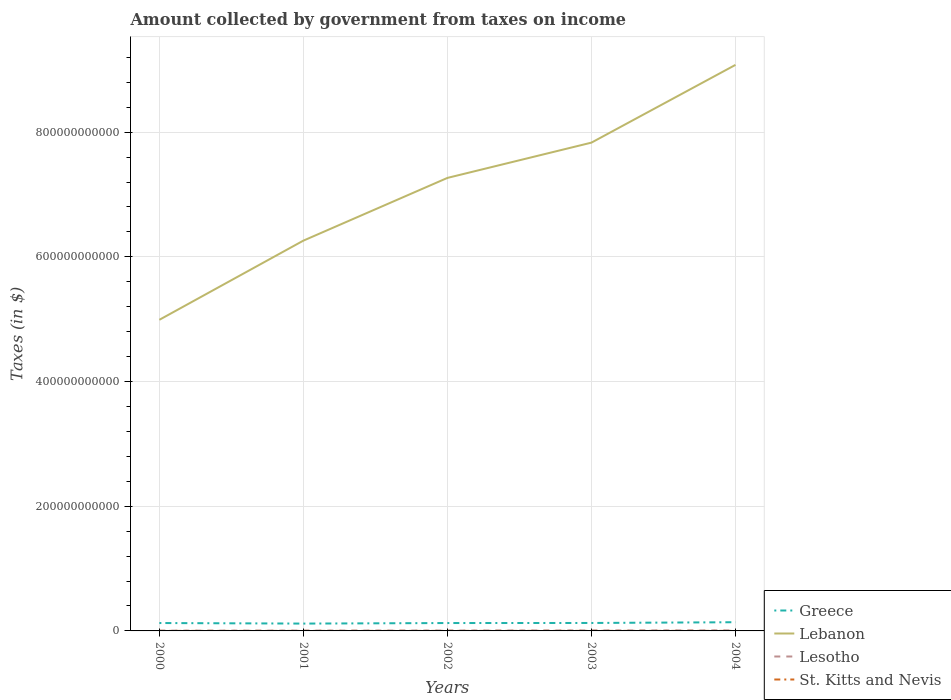How many different coloured lines are there?
Your response must be concise. 4. Across all years, what is the maximum amount collected by government from taxes on income in St. Kitts and Nevis?
Make the answer very short. 5.77e+07. In which year was the amount collected by government from taxes on income in St. Kitts and Nevis maximum?
Make the answer very short. 2001. What is the total amount collected by government from taxes on income in Lebanon in the graph?
Make the answer very short. -1.81e+11. What is the difference between the highest and the second highest amount collected by government from taxes on income in Greece?
Ensure brevity in your answer.  2.20e+09. How many lines are there?
Keep it short and to the point. 4. How many years are there in the graph?
Keep it short and to the point. 5. What is the difference between two consecutive major ticks on the Y-axis?
Offer a terse response. 2.00e+11. Are the values on the major ticks of Y-axis written in scientific E-notation?
Ensure brevity in your answer.  No. Does the graph contain any zero values?
Give a very brief answer. No. Does the graph contain grids?
Make the answer very short. Yes. Where does the legend appear in the graph?
Provide a succinct answer. Bottom right. How many legend labels are there?
Ensure brevity in your answer.  4. How are the legend labels stacked?
Provide a succinct answer. Vertical. What is the title of the graph?
Offer a very short reply. Amount collected by government from taxes on income. What is the label or title of the X-axis?
Your answer should be very brief. Years. What is the label or title of the Y-axis?
Ensure brevity in your answer.  Taxes (in $). What is the Taxes (in $) in Greece in 2000?
Your answer should be compact. 1.27e+1. What is the Taxes (in $) in Lebanon in 2000?
Your answer should be compact. 4.99e+11. What is the Taxes (in $) in Lesotho in 2000?
Your answer should be very brief. 4.68e+08. What is the Taxes (in $) in St. Kitts and Nevis in 2000?
Your response must be concise. 5.92e+07. What is the Taxes (in $) in Greece in 2001?
Offer a very short reply. 1.18e+1. What is the Taxes (in $) in Lebanon in 2001?
Your answer should be very brief. 6.26e+11. What is the Taxes (in $) of Lesotho in 2001?
Keep it short and to the point. 5.80e+08. What is the Taxes (in $) in St. Kitts and Nevis in 2001?
Your answer should be very brief. 5.77e+07. What is the Taxes (in $) of Greece in 2002?
Keep it short and to the point. 1.26e+1. What is the Taxes (in $) of Lebanon in 2002?
Provide a short and direct response. 7.27e+11. What is the Taxes (in $) of Lesotho in 2002?
Your answer should be very brief. 6.63e+08. What is the Taxes (in $) in St. Kitts and Nevis in 2002?
Make the answer very short. 6.19e+07. What is the Taxes (in $) in Greece in 2003?
Provide a succinct answer. 1.28e+1. What is the Taxes (in $) of Lebanon in 2003?
Offer a terse response. 7.83e+11. What is the Taxes (in $) in Lesotho in 2003?
Your answer should be compact. 8.44e+08. What is the Taxes (in $) of St. Kitts and Nevis in 2003?
Keep it short and to the point. 6.41e+07. What is the Taxes (in $) of Greece in 2004?
Keep it short and to the point. 1.40e+1. What is the Taxes (in $) in Lebanon in 2004?
Offer a very short reply. 9.08e+11. What is the Taxes (in $) in Lesotho in 2004?
Make the answer very short. 8.97e+08. What is the Taxes (in $) in St. Kitts and Nevis in 2004?
Provide a short and direct response. 8.04e+07. Across all years, what is the maximum Taxes (in $) of Greece?
Offer a terse response. 1.40e+1. Across all years, what is the maximum Taxes (in $) in Lebanon?
Ensure brevity in your answer.  9.08e+11. Across all years, what is the maximum Taxes (in $) in Lesotho?
Your answer should be compact. 8.97e+08. Across all years, what is the maximum Taxes (in $) of St. Kitts and Nevis?
Make the answer very short. 8.04e+07. Across all years, what is the minimum Taxes (in $) of Greece?
Provide a short and direct response. 1.18e+1. Across all years, what is the minimum Taxes (in $) in Lebanon?
Keep it short and to the point. 4.99e+11. Across all years, what is the minimum Taxes (in $) in Lesotho?
Make the answer very short. 4.68e+08. Across all years, what is the minimum Taxes (in $) in St. Kitts and Nevis?
Offer a very short reply. 5.77e+07. What is the total Taxes (in $) in Greece in the graph?
Offer a very short reply. 6.38e+1. What is the total Taxes (in $) in Lebanon in the graph?
Keep it short and to the point. 3.54e+12. What is the total Taxes (in $) of Lesotho in the graph?
Your answer should be very brief. 3.45e+09. What is the total Taxes (in $) in St. Kitts and Nevis in the graph?
Give a very brief answer. 3.23e+08. What is the difference between the Taxes (in $) of Greece in 2000 and that in 2001?
Ensure brevity in your answer.  8.96e+08. What is the difference between the Taxes (in $) in Lebanon in 2000 and that in 2001?
Your response must be concise. -1.27e+11. What is the difference between the Taxes (in $) in Lesotho in 2000 and that in 2001?
Provide a short and direct response. -1.11e+08. What is the difference between the Taxes (in $) in St. Kitts and Nevis in 2000 and that in 2001?
Offer a terse response. 1.50e+06. What is the difference between the Taxes (in $) in Greece in 2000 and that in 2002?
Give a very brief answer. 1.40e+07. What is the difference between the Taxes (in $) in Lebanon in 2000 and that in 2002?
Your answer should be very brief. -2.28e+11. What is the difference between the Taxes (in $) of Lesotho in 2000 and that in 2002?
Provide a succinct answer. -1.95e+08. What is the difference between the Taxes (in $) in St. Kitts and Nevis in 2000 and that in 2002?
Give a very brief answer. -2.70e+06. What is the difference between the Taxes (in $) of Greece in 2000 and that in 2003?
Your answer should be very brief. -8.70e+07. What is the difference between the Taxes (in $) in Lebanon in 2000 and that in 2003?
Your answer should be very brief. -2.84e+11. What is the difference between the Taxes (in $) of Lesotho in 2000 and that in 2003?
Provide a succinct answer. -3.76e+08. What is the difference between the Taxes (in $) in St. Kitts and Nevis in 2000 and that in 2003?
Offer a very short reply. -4.90e+06. What is the difference between the Taxes (in $) in Greece in 2000 and that in 2004?
Your response must be concise. -1.30e+09. What is the difference between the Taxes (in $) of Lebanon in 2000 and that in 2004?
Your answer should be very brief. -4.09e+11. What is the difference between the Taxes (in $) of Lesotho in 2000 and that in 2004?
Make the answer very short. -4.29e+08. What is the difference between the Taxes (in $) in St. Kitts and Nevis in 2000 and that in 2004?
Your answer should be compact. -2.12e+07. What is the difference between the Taxes (in $) of Greece in 2001 and that in 2002?
Keep it short and to the point. -8.82e+08. What is the difference between the Taxes (in $) in Lebanon in 2001 and that in 2002?
Give a very brief answer. -1.01e+11. What is the difference between the Taxes (in $) of Lesotho in 2001 and that in 2002?
Offer a very short reply. -8.36e+07. What is the difference between the Taxes (in $) in St. Kitts and Nevis in 2001 and that in 2002?
Your response must be concise. -4.20e+06. What is the difference between the Taxes (in $) of Greece in 2001 and that in 2003?
Give a very brief answer. -9.83e+08. What is the difference between the Taxes (in $) of Lebanon in 2001 and that in 2003?
Provide a succinct answer. -1.57e+11. What is the difference between the Taxes (in $) in Lesotho in 2001 and that in 2003?
Your answer should be compact. -2.65e+08. What is the difference between the Taxes (in $) in St. Kitts and Nevis in 2001 and that in 2003?
Offer a terse response. -6.40e+06. What is the difference between the Taxes (in $) of Greece in 2001 and that in 2004?
Your response must be concise. -2.20e+09. What is the difference between the Taxes (in $) of Lebanon in 2001 and that in 2004?
Your answer should be compact. -2.82e+11. What is the difference between the Taxes (in $) in Lesotho in 2001 and that in 2004?
Make the answer very short. -3.17e+08. What is the difference between the Taxes (in $) in St. Kitts and Nevis in 2001 and that in 2004?
Provide a short and direct response. -2.27e+07. What is the difference between the Taxes (in $) in Greece in 2002 and that in 2003?
Your response must be concise. -1.01e+08. What is the difference between the Taxes (in $) of Lebanon in 2002 and that in 2003?
Keep it short and to the point. -5.66e+1. What is the difference between the Taxes (in $) of Lesotho in 2002 and that in 2003?
Your answer should be compact. -1.81e+08. What is the difference between the Taxes (in $) of St. Kitts and Nevis in 2002 and that in 2003?
Ensure brevity in your answer.  -2.20e+06. What is the difference between the Taxes (in $) in Greece in 2002 and that in 2004?
Your response must be concise. -1.31e+09. What is the difference between the Taxes (in $) of Lebanon in 2002 and that in 2004?
Ensure brevity in your answer.  -1.81e+11. What is the difference between the Taxes (in $) of Lesotho in 2002 and that in 2004?
Offer a terse response. -2.34e+08. What is the difference between the Taxes (in $) of St. Kitts and Nevis in 2002 and that in 2004?
Provide a short and direct response. -1.85e+07. What is the difference between the Taxes (in $) of Greece in 2003 and that in 2004?
Provide a succinct answer. -1.21e+09. What is the difference between the Taxes (in $) of Lebanon in 2003 and that in 2004?
Keep it short and to the point. -1.25e+11. What is the difference between the Taxes (in $) of Lesotho in 2003 and that in 2004?
Ensure brevity in your answer.  -5.27e+07. What is the difference between the Taxes (in $) in St. Kitts and Nevis in 2003 and that in 2004?
Offer a very short reply. -1.63e+07. What is the difference between the Taxes (in $) in Greece in 2000 and the Taxes (in $) in Lebanon in 2001?
Your answer should be very brief. -6.13e+11. What is the difference between the Taxes (in $) in Greece in 2000 and the Taxes (in $) in Lesotho in 2001?
Keep it short and to the point. 1.21e+1. What is the difference between the Taxes (in $) in Greece in 2000 and the Taxes (in $) in St. Kitts and Nevis in 2001?
Your answer should be compact. 1.26e+1. What is the difference between the Taxes (in $) in Lebanon in 2000 and the Taxes (in $) in Lesotho in 2001?
Provide a succinct answer. 4.98e+11. What is the difference between the Taxes (in $) in Lebanon in 2000 and the Taxes (in $) in St. Kitts and Nevis in 2001?
Make the answer very short. 4.99e+11. What is the difference between the Taxes (in $) in Lesotho in 2000 and the Taxes (in $) in St. Kitts and Nevis in 2001?
Offer a very short reply. 4.11e+08. What is the difference between the Taxes (in $) of Greece in 2000 and the Taxes (in $) of Lebanon in 2002?
Provide a short and direct response. -7.14e+11. What is the difference between the Taxes (in $) in Greece in 2000 and the Taxes (in $) in Lesotho in 2002?
Provide a succinct answer. 1.20e+1. What is the difference between the Taxes (in $) of Greece in 2000 and the Taxes (in $) of St. Kitts and Nevis in 2002?
Keep it short and to the point. 1.26e+1. What is the difference between the Taxes (in $) in Lebanon in 2000 and the Taxes (in $) in Lesotho in 2002?
Your answer should be very brief. 4.98e+11. What is the difference between the Taxes (in $) in Lebanon in 2000 and the Taxes (in $) in St. Kitts and Nevis in 2002?
Ensure brevity in your answer.  4.99e+11. What is the difference between the Taxes (in $) in Lesotho in 2000 and the Taxes (in $) in St. Kitts and Nevis in 2002?
Your answer should be compact. 4.07e+08. What is the difference between the Taxes (in $) in Greece in 2000 and the Taxes (in $) in Lebanon in 2003?
Make the answer very short. -7.71e+11. What is the difference between the Taxes (in $) in Greece in 2000 and the Taxes (in $) in Lesotho in 2003?
Keep it short and to the point. 1.18e+1. What is the difference between the Taxes (in $) in Greece in 2000 and the Taxes (in $) in St. Kitts and Nevis in 2003?
Your answer should be very brief. 1.26e+1. What is the difference between the Taxes (in $) in Lebanon in 2000 and the Taxes (in $) in Lesotho in 2003?
Provide a short and direct response. 4.98e+11. What is the difference between the Taxes (in $) of Lebanon in 2000 and the Taxes (in $) of St. Kitts and Nevis in 2003?
Your answer should be very brief. 4.99e+11. What is the difference between the Taxes (in $) in Lesotho in 2000 and the Taxes (in $) in St. Kitts and Nevis in 2003?
Provide a succinct answer. 4.04e+08. What is the difference between the Taxes (in $) in Greece in 2000 and the Taxes (in $) in Lebanon in 2004?
Offer a terse response. -8.95e+11. What is the difference between the Taxes (in $) of Greece in 2000 and the Taxes (in $) of Lesotho in 2004?
Your response must be concise. 1.18e+1. What is the difference between the Taxes (in $) in Greece in 2000 and the Taxes (in $) in St. Kitts and Nevis in 2004?
Your answer should be compact. 1.26e+1. What is the difference between the Taxes (in $) in Lebanon in 2000 and the Taxes (in $) in Lesotho in 2004?
Give a very brief answer. 4.98e+11. What is the difference between the Taxes (in $) of Lebanon in 2000 and the Taxes (in $) of St. Kitts and Nevis in 2004?
Your answer should be compact. 4.99e+11. What is the difference between the Taxes (in $) in Lesotho in 2000 and the Taxes (in $) in St. Kitts and Nevis in 2004?
Make the answer very short. 3.88e+08. What is the difference between the Taxes (in $) of Greece in 2001 and the Taxes (in $) of Lebanon in 2002?
Provide a short and direct response. -7.15e+11. What is the difference between the Taxes (in $) of Greece in 2001 and the Taxes (in $) of Lesotho in 2002?
Your answer should be compact. 1.11e+1. What is the difference between the Taxes (in $) in Greece in 2001 and the Taxes (in $) in St. Kitts and Nevis in 2002?
Keep it short and to the point. 1.17e+1. What is the difference between the Taxes (in $) of Lebanon in 2001 and the Taxes (in $) of Lesotho in 2002?
Provide a succinct answer. 6.25e+11. What is the difference between the Taxes (in $) of Lebanon in 2001 and the Taxes (in $) of St. Kitts and Nevis in 2002?
Your response must be concise. 6.26e+11. What is the difference between the Taxes (in $) of Lesotho in 2001 and the Taxes (in $) of St. Kitts and Nevis in 2002?
Your response must be concise. 5.18e+08. What is the difference between the Taxes (in $) of Greece in 2001 and the Taxes (in $) of Lebanon in 2003?
Provide a succinct answer. -7.71e+11. What is the difference between the Taxes (in $) of Greece in 2001 and the Taxes (in $) of Lesotho in 2003?
Provide a succinct answer. 1.09e+1. What is the difference between the Taxes (in $) in Greece in 2001 and the Taxes (in $) in St. Kitts and Nevis in 2003?
Offer a very short reply. 1.17e+1. What is the difference between the Taxes (in $) of Lebanon in 2001 and the Taxes (in $) of Lesotho in 2003?
Keep it short and to the point. 6.25e+11. What is the difference between the Taxes (in $) of Lebanon in 2001 and the Taxes (in $) of St. Kitts and Nevis in 2003?
Offer a very short reply. 6.26e+11. What is the difference between the Taxes (in $) of Lesotho in 2001 and the Taxes (in $) of St. Kitts and Nevis in 2003?
Make the answer very short. 5.16e+08. What is the difference between the Taxes (in $) of Greece in 2001 and the Taxes (in $) of Lebanon in 2004?
Your answer should be very brief. -8.96e+11. What is the difference between the Taxes (in $) of Greece in 2001 and the Taxes (in $) of Lesotho in 2004?
Make the answer very short. 1.09e+1. What is the difference between the Taxes (in $) in Greece in 2001 and the Taxes (in $) in St. Kitts and Nevis in 2004?
Provide a short and direct response. 1.17e+1. What is the difference between the Taxes (in $) of Lebanon in 2001 and the Taxes (in $) of Lesotho in 2004?
Give a very brief answer. 6.25e+11. What is the difference between the Taxes (in $) in Lebanon in 2001 and the Taxes (in $) in St. Kitts and Nevis in 2004?
Keep it short and to the point. 6.26e+11. What is the difference between the Taxes (in $) of Lesotho in 2001 and the Taxes (in $) of St. Kitts and Nevis in 2004?
Offer a very short reply. 4.99e+08. What is the difference between the Taxes (in $) in Greece in 2002 and the Taxes (in $) in Lebanon in 2003?
Provide a short and direct response. -7.71e+11. What is the difference between the Taxes (in $) of Greece in 2002 and the Taxes (in $) of Lesotho in 2003?
Offer a very short reply. 1.18e+1. What is the difference between the Taxes (in $) of Greece in 2002 and the Taxes (in $) of St. Kitts and Nevis in 2003?
Keep it short and to the point. 1.26e+1. What is the difference between the Taxes (in $) of Lebanon in 2002 and the Taxes (in $) of Lesotho in 2003?
Offer a terse response. 7.26e+11. What is the difference between the Taxes (in $) in Lebanon in 2002 and the Taxes (in $) in St. Kitts and Nevis in 2003?
Offer a terse response. 7.27e+11. What is the difference between the Taxes (in $) of Lesotho in 2002 and the Taxes (in $) of St. Kitts and Nevis in 2003?
Provide a succinct answer. 5.99e+08. What is the difference between the Taxes (in $) in Greece in 2002 and the Taxes (in $) in Lebanon in 2004?
Offer a very short reply. -8.95e+11. What is the difference between the Taxes (in $) in Greece in 2002 and the Taxes (in $) in Lesotho in 2004?
Keep it short and to the point. 1.18e+1. What is the difference between the Taxes (in $) in Greece in 2002 and the Taxes (in $) in St. Kitts and Nevis in 2004?
Make the answer very short. 1.26e+1. What is the difference between the Taxes (in $) of Lebanon in 2002 and the Taxes (in $) of Lesotho in 2004?
Keep it short and to the point. 7.26e+11. What is the difference between the Taxes (in $) in Lebanon in 2002 and the Taxes (in $) in St. Kitts and Nevis in 2004?
Keep it short and to the point. 7.27e+11. What is the difference between the Taxes (in $) in Lesotho in 2002 and the Taxes (in $) in St. Kitts and Nevis in 2004?
Provide a succinct answer. 5.83e+08. What is the difference between the Taxes (in $) of Greece in 2003 and the Taxes (in $) of Lebanon in 2004?
Offer a terse response. -8.95e+11. What is the difference between the Taxes (in $) in Greece in 2003 and the Taxes (in $) in Lesotho in 2004?
Ensure brevity in your answer.  1.19e+1. What is the difference between the Taxes (in $) of Greece in 2003 and the Taxes (in $) of St. Kitts and Nevis in 2004?
Give a very brief answer. 1.27e+1. What is the difference between the Taxes (in $) in Lebanon in 2003 and the Taxes (in $) in Lesotho in 2004?
Your response must be concise. 7.82e+11. What is the difference between the Taxes (in $) of Lebanon in 2003 and the Taxes (in $) of St. Kitts and Nevis in 2004?
Your answer should be very brief. 7.83e+11. What is the difference between the Taxes (in $) in Lesotho in 2003 and the Taxes (in $) in St. Kitts and Nevis in 2004?
Keep it short and to the point. 7.64e+08. What is the average Taxes (in $) of Greece per year?
Your answer should be very brief. 1.28e+1. What is the average Taxes (in $) in Lebanon per year?
Provide a succinct answer. 7.09e+11. What is the average Taxes (in $) in Lesotho per year?
Your answer should be very brief. 6.91e+08. What is the average Taxes (in $) of St. Kitts and Nevis per year?
Ensure brevity in your answer.  6.47e+07. In the year 2000, what is the difference between the Taxes (in $) in Greece and Taxes (in $) in Lebanon?
Offer a terse response. -4.86e+11. In the year 2000, what is the difference between the Taxes (in $) in Greece and Taxes (in $) in Lesotho?
Ensure brevity in your answer.  1.22e+1. In the year 2000, what is the difference between the Taxes (in $) in Greece and Taxes (in $) in St. Kitts and Nevis?
Provide a short and direct response. 1.26e+1. In the year 2000, what is the difference between the Taxes (in $) in Lebanon and Taxes (in $) in Lesotho?
Your answer should be very brief. 4.99e+11. In the year 2000, what is the difference between the Taxes (in $) of Lebanon and Taxes (in $) of St. Kitts and Nevis?
Give a very brief answer. 4.99e+11. In the year 2000, what is the difference between the Taxes (in $) in Lesotho and Taxes (in $) in St. Kitts and Nevis?
Your response must be concise. 4.09e+08. In the year 2001, what is the difference between the Taxes (in $) of Greece and Taxes (in $) of Lebanon?
Provide a short and direct response. -6.14e+11. In the year 2001, what is the difference between the Taxes (in $) in Greece and Taxes (in $) in Lesotho?
Offer a terse response. 1.12e+1. In the year 2001, what is the difference between the Taxes (in $) in Greece and Taxes (in $) in St. Kitts and Nevis?
Your answer should be very brief. 1.17e+1. In the year 2001, what is the difference between the Taxes (in $) of Lebanon and Taxes (in $) of Lesotho?
Ensure brevity in your answer.  6.25e+11. In the year 2001, what is the difference between the Taxes (in $) in Lebanon and Taxes (in $) in St. Kitts and Nevis?
Offer a very short reply. 6.26e+11. In the year 2001, what is the difference between the Taxes (in $) of Lesotho and Taxes (in $) of St. Kitts and Nevis?
Keep it short and to the point. 5.22e+08. In the year 2002, what is the difference between the Taxes (in $) in Greece and Taxes (in $) in Lebanon?
Make the answer very short. -7.14e+11. In the year 2002, what is the difference between the Taxes (in $) of Greece and Taxes (in $) of Lesotho?
Offer a very short reply. 1.20e+1. In the year 2002, what is the difference between the Taxes (in $) of Greece and Taxes (in $) of St. Kitts and Nevis?
Make the answer very short. 1.26e+1. In the year 2002, what is the difference between the Taxes (in $) of Lebanon and Taxes (in $) of Lesotho?
Give a very brief answer. 7.26e+11. In the year 2002, what is the difference between the Taxes (in $) of Lebanon and Taxes (in $) of St. Kitts and Nevis?
Your response must be concise. 7.27e+11. In the year 2002, what is the difference between the Taxes (in $) in Lesotho and Taxes (in $) in St. Kitts and Nevis?
Keep it short and to the point. 6.01e+08. In the year 2003, what is the difference between the Taxes (in $) in Greece and Taxes (in $) in Lebanon?
Your answer should be compact. -7.70e+11. In the year 2003, what is the difference between the Taxes (in $) in Greece and Taxes (in $) in Lesotho?
Keep it short and to the point. 1.19e+1. In the year 2003, what is the difference between the Taxes (in $) in Greece and Taxes (in $) in St. Kitts and Nevis?
Provide a short and direct response. 1.27e+1. In the year 2003, what is the difference between the Taxes (in $) of Lebanon and Taxes (in $) of Lesotho?
Provide a short and direct response. 7.82e+11. In the year 2003, what is the difference between the Taxes (in $) in Lebanon and Taxes (in $) in St. Kitts and Nevis?
Provide a succinct answer. 7.83e+11. In the year 2003, what is the difference between the Taxes (in $) in Lesotho and Taxes (in $) in St. Kitts and Nevis?
Offer a very short reply. 7.80e+08. In the year 2004, what is the difference between the Taxes (in $) in Greece and Taxes (in $) in Lebanon?
Ensure brevity in your answer.  -8.94e+11. In the year 2004, what is the difference between the Taxes (in $) of Greece and Taxes (in $) of Lesotho?
Make the answer very short. 1.31e+1. In the year 2004, what is the difference between the Taxes (in $) in Greece and Taxes (in $) in St. Kitts and Nevis?
Keep it short and to the point. 1.39e+1. In the year 2004, what is the difference between the Taxes (in $) in Lebanon and Taxes (in $) in Lesotho?
Make the answer very short. 9.07e+11. In the year 2004, what is the difference between the Taxes (in $) of Lebanon and Taxes (in $) of St. Kitts and Nevis?
Offer a very short reply. 9.08e+11. In the year 2004, what is the difference between the Taxes (in $) of Lesotho and Taxes (in $) of St. Kitts and Nevis?
Keep it short and to the point. 8.17e+08. What is the ratio of the Taxes (in $) in Greece in 2000 to that in 2001?
Your answer should be compact. 1.08. What is the ratio of the Taxes (in $) in Lebanon in 2000 to that in 2001?
Your answer should be very brief. 0.8. What is the ratio of the Taxes (in $) of Lesotho in 2000 to that in 2001?
Give a very brief answer. 0.81. What is the ratio of the Taxes (in $) of Greece in 2000 to that in 2002?
Your response must be concise. 1. What is the ratio of the Taxes (in $) in Lebanon in 2000 to that in 2002?
Provide a succinct answer. 0.69. What is the ratio of the Taxes (in $) in Lesotho in 2000 to that in 2002?
Offer a terse response. 0.71. What is the ratio of the Taxes (in $) of St. Kitts and Nevis in 2000 to that in 2002?
Provide a short and direct response. 0.96. What is the ratio of the Taxes (in $) of Greece in 2000 to that in 2003?
Make the answer very short. 0.99. What is the ratio of the Taxes (in $) of Lebanon in 2000 to that in 2003?
Give a very brief answer. 0.64. What is the ratio of the Taxes (in $) in Lesotho in 2000 to that in 2003?
Offer a terse response. 0.55. What is the ratio of the Taxes (in $) of St. Kitts and Nevis in 2000 to that in 2003?
Make the answer very short. 0.92. What is the ratio of the Taxes (in $) in Greece in 2000 to that in 2004?
Offer a terse response. 0.91. What is the ratio of the Taxes (in $) in Lebanon in 2000 to that in 2004?
Give a very brief answer. 0.55. What is the ratio of the Taxes (in $) of Lesotho in 2000 to that in 2004?
Provide a short and direct response. 0.52. What is the ratio of the Taxes (in $) of St. Kitts and Nevis in 2000 to that in 2004?
Give a very brief answer. 0.74. What is the ratio of the Taxes (in $) in Greece in 2001 to that in 2002?
Your response must be concise. 0.93. What is the ratio of the Taxes (in $) of Lebanon in 2001 to that in 2002?
Your answer should be very brief. 0.86. What is the ratio of the Taxes (in $) in Lesotho in 2001 to that in 2002?
Ensure brevity in your answer.  0.87. What is the ratio of the Taxes (in $) in St. Kitts and Nevis in 2001 to that in 2002?
Provide a succinct answer. 0.93. What is the ratio of the Taxes (in $) in Greece in 2001 to that in 2003?
Provide a short and direct response. 0.92. What is the ratio of the Taxes (in $) in Lebanon in 2001 to that in 2003?
Provide a succinct answer. 0.8. What is the ratio of the Taxes (in $) in Lesotho in 2001 to that in 2003?
Ensure brevity in your answer.  0.69. What is the ratio of the Taxes (in $) in St. Kitts and Nevis in 2001 to that in 2003?
Give a very brief answer. 0.9. What is the ratio of the Taxes (in $) of Greece in 2001 to that in 2004?
Provide a short and direct response. 0.84. What is the ratio of the Taxes (in $) of Lebanon in 2001 to that in 2004?
Keep it short and to the point. 0.69. What is the ratio of the Taxes (in $) in Lesotho in 2001 to that in 2004?
Keep it short and to the point. 0.65. What is the ratio of the Taxes (in $) in St. Kitts and Nevis in 2001 to that in 2004?
Offer a very short reply. 0.72. What is the ratio of the Taxes (in $) in Greece in 2002 to that in 2003?
Your answer should be compact. 0.99. What is the ratio of the Taxes (in $) of Lebanon in 2002 to that in 2003?
Ensure brevity in your answer.  0.93. What is the ratio of the Taxes (in $) in Lesotho in 2002 to that in 2003?
Provide a short and direct response. 0.79. What is the ratio of the Taxes (in $) of St. Kitts and Nevis in 2002 to that in 2003?
Ensure brevity in your answer.  0.97. What is the ratio of the Taxes (in $) in Greece in 2002 to that in 2004?
Keep it short and to the point. 0.91. What is the ratio of the Taxes (in $) of Lebanon in 2002 to that in 2004?
Make the answer very short. 0.8. What is the ratio of the Taxes (in $) in Lesotho in 2002 to that in 2004?
Ensure brevity in your answer.  0.74. What is the ratio of the Taxes (in $) of St. Kitts and Nevis in 2002 to that in 2004?
Make the answer very short. 0.77. What is the ratio of the Taxes (in $) of Greece in 2003 to that in 2004?
Provide a short and direct response. 0.91. What is the ratio of the Taxes (in $) of Lebanon in 2003 to that in 2004?
Your response must be concise. 0.86. What is the ratio of the Taxes (in $) of Lesotho in 2003 to that in 2004?
Your answer should be very brief. 0.94. What is the ratio of the Taxes (in $) of St. Kitts and Nevis in 2003 to that in 2004?
Offer a terse response. 0.8. What is the difference between the highest and the second highest Taxes (in $) in Greece?
Provide a short and direct response. 1.21e+09. What is the difference between the highest and the second highest Taxes (in $) in Lebanon?
Provide a short and direct response. 1.25e+11. What is the difference between the highest and the second highest Taxes (in $) of Lesotho?
Your answer should be compact. 5.27e+07. What is the difference between the highest and the second highest Taxes (in $) of St. Kitts and Nevis?
Make the answer very short. 1.63e+07. What is the difference between the highest and the lowest Taxes (in $) in Greece?
Your response must be concise. 2.20e+09. What is the difference between the highest and the lowest Taxes (in $) of Lebanon?
Your answer should be very brief. 4.09e+11. What is the difference between the highest and the lowest Taxes (in $) in Lesotho?
Offer a terse response. 4.29e+08. What is the difference between the highest and the lowest Taxes (in $) of St. Kitts and Nevis?
Offer a very short reply. 2.27e+07. 